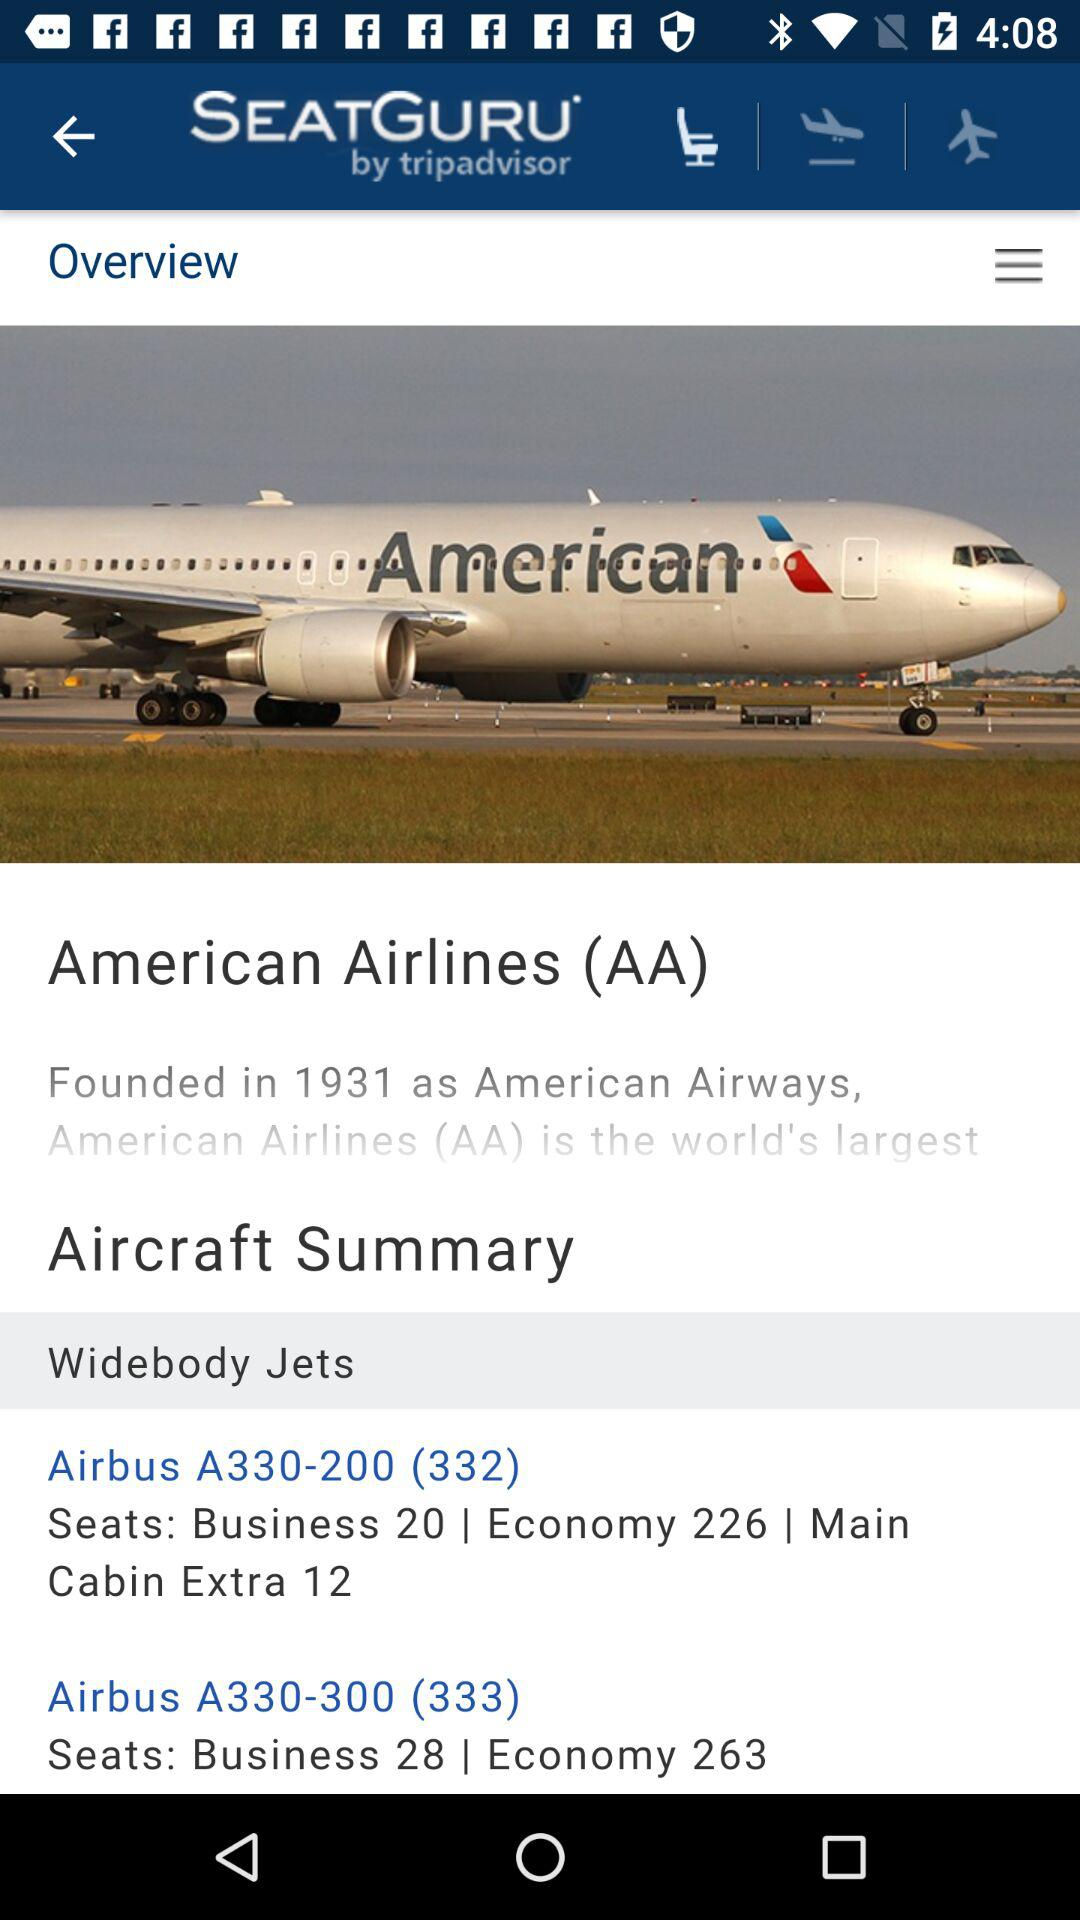How many seats are there in the Main Cabin Extra of the Airbus A330-200?
Answer the question using a single word or phrase. 12 